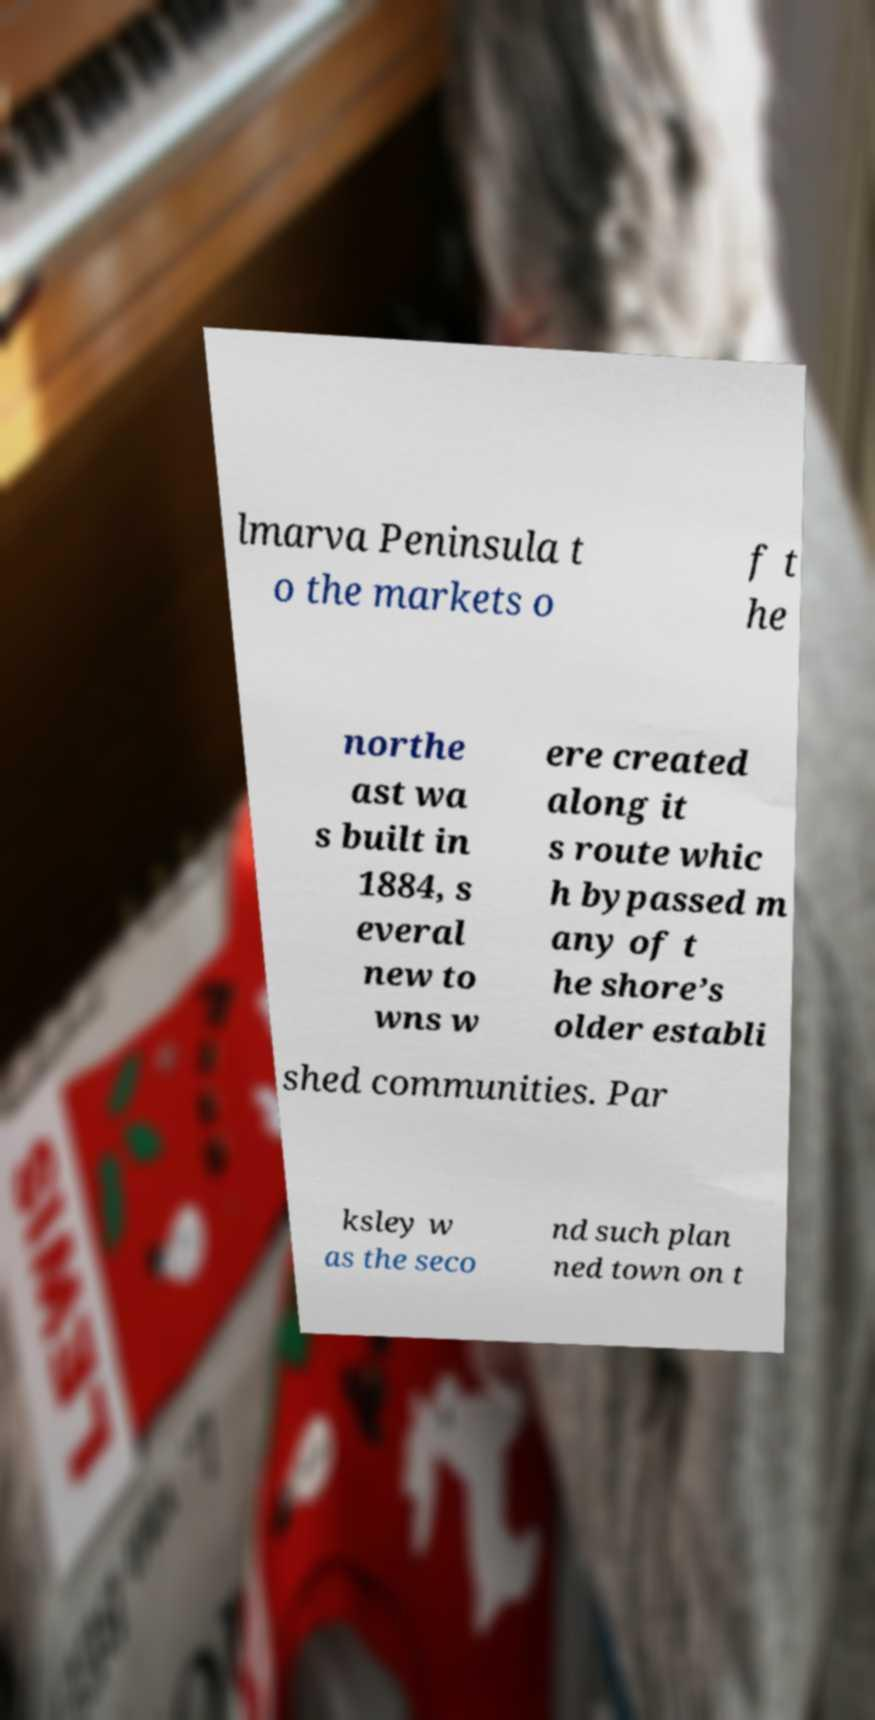Please identify and transcribe the text found in this image. lmarva Peninsula t o the markets o f t he northe ast wa s built in 1884, s everal new to wns w ere created along it s route whic h bypassed m any of t he shore’s older establi shed communities. Par ksley w as the seco nd such plan ned town on t 